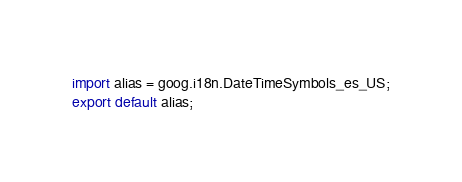Convert code to text. <code><loc_0><loc_0><loc_500><loc_500><_TypeScript_>
import alias = goog.i18n.DateTimeSymbols_es_US;
export default alias;
</code> 